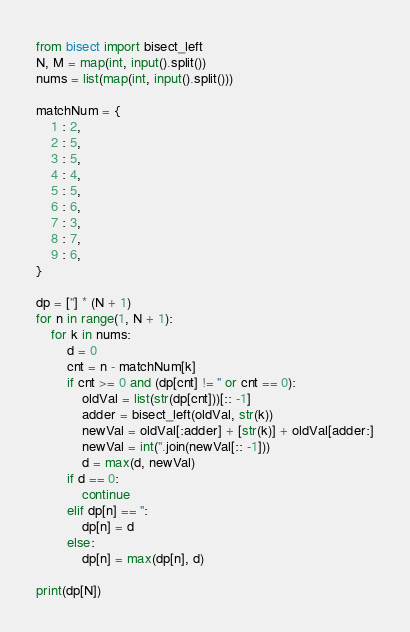<code> <loc_0><loc_0><loc_500><loc_500><_Python_>from bisect import bisect_left
N, M = map(int, input().split())
nums = list(map(int, input().split()))

matchNum = {
    1 : 2,
    2 : 5,
    3 : 5,
    4 : 4,
    5 : 5,
    6 : 6,
    7 : 3,
    8 : 7,
    9 : 6,
}

dp = [''] * (N + 1)
for n in range(1, N + 1):
    for k in nums:
        d = 0
        cnt = n - matchNum[k]
        if cnt >= 0 and (dp[cnt] != '' or cnt == 0):
            oldVal = list(str(dp[cnt]))[:: -1]
            adder = bisect_left(oldVal, str(k))
            newVal = oldVal[:adder] + [str(k)] + oldVal[adder:]
            newVal = int(''.join(newVal[:: -1]))
            d = max(d, newVal)
        if d == 0:
            continue
        elif dp[n] == '':
            dp[n] = d
        else:
            dp[n] = max(dp[n], d)

print(dp[N])</code> 